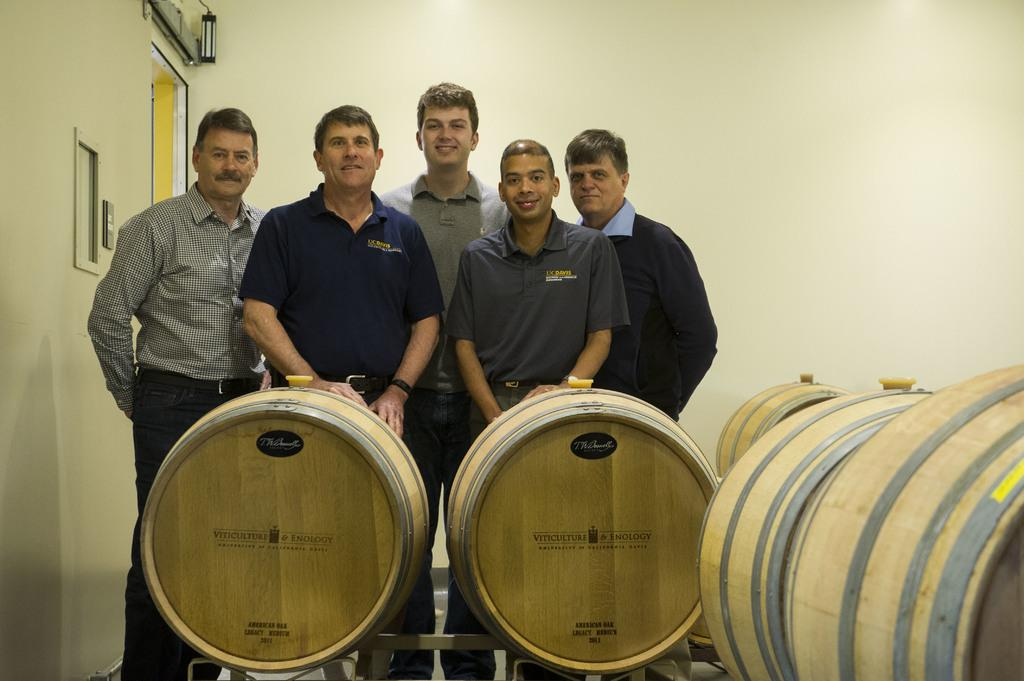What are the people in the image doing? There is a group of people standing on the floor in the image. What objects can be seen in the image related to music? There are wooden drums in the image. What type of structure is visible in the background? There is a wall visible in the image, and a door is also present. What type of bird can be seen singing near the door in the image? There is no bird present in the image, and therefore no bird can be seen singing near the door. 